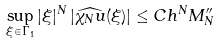Convert formula to latex. <formula><loc_0><loc_0><loc_500><loc_500>\sup _ { \xi \in \Gamma _ { 1 } } | \xi | ^ { N } \left | \widehat { \chi _ { N } u } ( \xi ) \right | \leq C h ^ { N } M ^ { \prime \prime } _ { N }</formula> 